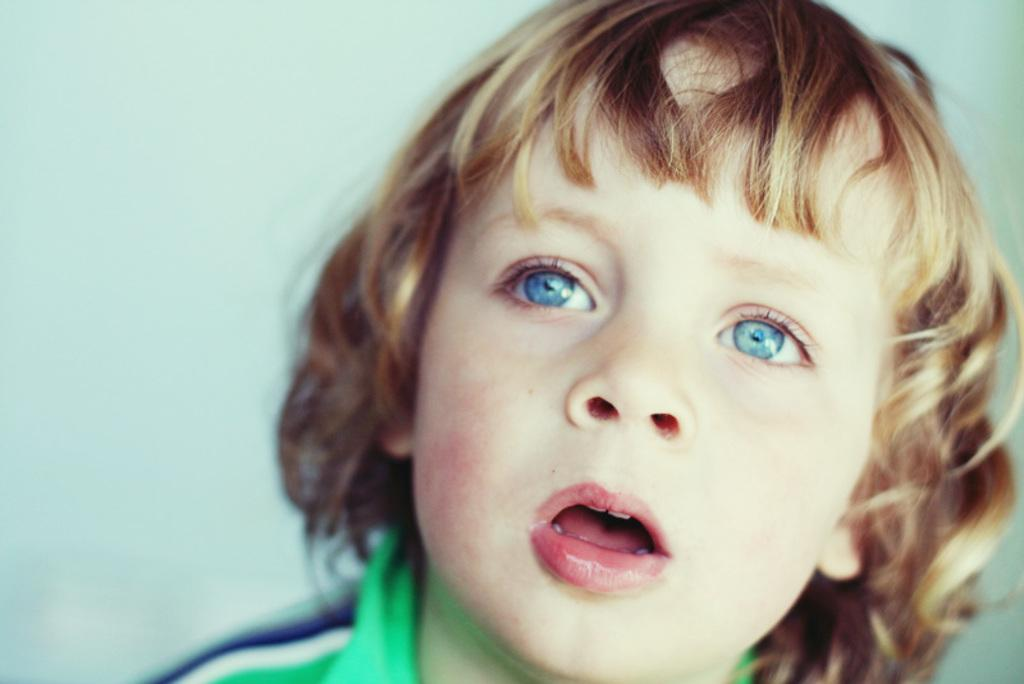What is the main subject of the image? The main subject of the image is a kid. What is the kid wearing in the image? The kid is wearing a green color shirt. What color can be seen in the background of the image? The background of the image has blue color visible. What type of sound can be heard coming from the toys in the image? There are no toys present in the image, so it's not possible to determine what, if any, sounds might be heard. 